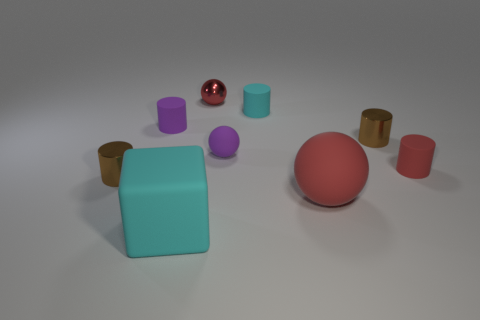Are there any reflective objects in the scene? Yes, there is a reflective, shiny sphere in the center of the image that appears to be metallic due to its reflective surface and its color, distinguishing it from the other matte objects. What can you infer about the light source in this scene? The shadows cast by the objects and the highlights on the reflective sphere suggest that there is a primary light source positioned above and possibly slightly to the front of the scene, illuminating the objects from above. 